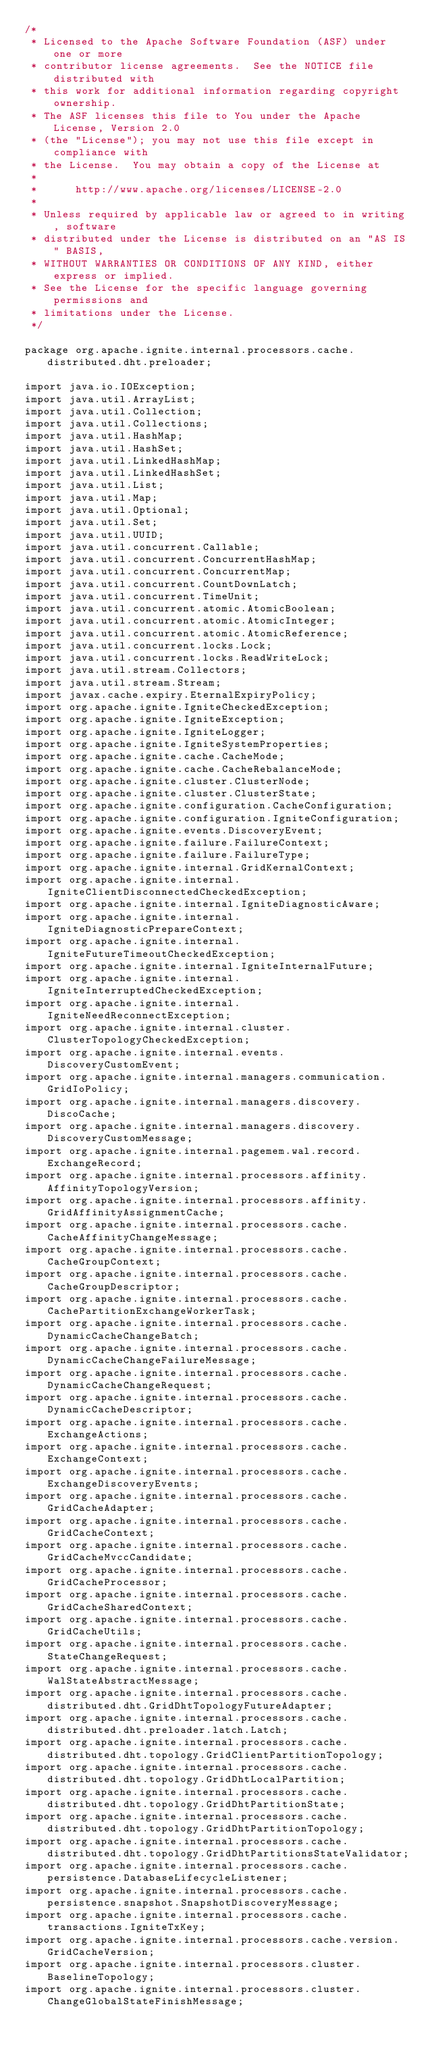<code> <loc_0><loc_0><loc_500><loc_500><_Java_>/*
 * Licensed to the Apache Software Foundation (ASF) under one or more
 * contributor license agreements.  See the NOTICE file distributed with
 * this work for additional information regarding copyright ownership.
 * The ASF licenses this file to You under the Apache License, Version 2.0
 * (the "License"); you may not use this file except in compliance with
 * the License.  You may obtain a copy of the License at
 *
 *      http://www.apache.org/licenses/LICENSE-2.0
 *
 * Unless required by applicable law or agreed to in writing, software
 * distributed under the License is distributed on an "AS IS" BASIS,
 * WITHOUT WARRANTIES OR CONDITIONS OF ANY KIND, either express or implied.
 * See the License for the specific language governing permissions and
 * limitations under the License.
 */

package org.apache.ignite.internal.processors.cache.distributed.dht.preloader;

import java.io.IOException;
import java.util.ArrayList;
import java.util.Collection;
import java.util.Collections;
import java.util.HashMap;
import java.util.HashSet;
import java.util.LinkedHashMap;
import java.util.LinkedHashSet;
import java.util.List;
import java.util.Map;
import java.util.Optional;
import java.util.Set;
import java.util.UUID;
import java.util.concurrent.Callable;
import java.util.concurrent.ConcurrentHashMap;
import java.util.concurrent.ConcurrentMap;
import java.util.concurrent.CountDownLatch;
import java.util.concurrent.TimeUnit;
import java.util.concurrent.atomic.AtomicBoolean;
import java.util.concurrent.atomic.AtomicInteger;
import java.util.concurrent.atomic.AtomicReference;
import java.util.concurrent.locks.Lock;
import java.util.concurrent.locks.ReadWriteLock;
import java.util.stream.Collectors;
import java.util.stream.Stream;
import javax.cache.expiry.EternalExpiryPolicy;
import org.apache.ignite.IgniteCheckedException;
import org.apache.ignite.IgniteException;
import org.apache.ignite.IgniteLogger;
import org.apache.ignite.IgniteSystemProperties;
import org.apache.ignite.cache.CacheMode;
import org.apache.ignite.cache.CacheRebalanceMode;
import org.apache.ignite.cluster.ClusterNode;
import org.apache.ignite.cluster.ClusterState;
import org.apache.ignite.configuration.CacheConfiguration;
import org.apache.ignite.configuration.IgniteConfiguration;
import org.apache.ignite.events.DiscoveryEvent;
import org.apache.ignite.failure.FailureContext;
import org.apache.ignite.failure.FailureType;
import org.apache.ignite.internal.GridKernalContext;
import org.apache.ignite.internal.IgniteClientDisconnectedCheckedException;
import org.apache.ignite.internal.IgniteDiagnosticAware;
import org.apache.ignite.internal.IgniteDiagnosticPrepareContext;
import org.apache.ignite.internal.IgniteFutureTimeoutCheckedException;
import org.apache.ignite.internal.IgniteInternalFuture;
import org.apache.ignite.internal.IgniteInterruptedCheckedException;
import org.apache.ignite.internal.IgniteNeedReconnectException;
import org.apache.ignite.internal.cluster.ClusterTopologyCheckedException;
import org.apache.ignite.internal.events.DiscoveryCustomEvent;
import org.apache.ignite.internal.managers.communication.GridIoPolicy;
import org.apache.ignite.internal.managers.discovery.DiscoCache;
import org.apache.ignite.internal.managers.discovery.DiscoveryCustomMessage;
import org.apache.ignite.internal.pagemem.wal.record.ExchangeRecord;
import org.apache.ignite.internal.processors.affinity.AffinityTopologyVersion;
import org.apache.ignite.internal.processors.affinity.GridAffinityAssignmentCache;
import org.apache.ignite.internal.processors.cache.CacheAffinityChangeMessage;
import org.apache.ignite.internal.processors.cache.CacheGroupContext;
import org.apache.ignite.internal.processors.cache.CacheGroupDescriptor;
import org.apache.ignite.internal.processors.cache.CachePartitionExchangeWorkerTask;
import org.apache.ignite.internal.processors.cache.DynamicCacheChangeBatch;
import org.apache.ignite.internal.processors.cache.DynamicCacheChangeFailureMessage;
import org.apache.ignite.internal.processors.cache.DynamicCacheChangeRequest;
import org.apache.ignite.internal.processors.cache.DynamicCacheDescriptor;
import org.apache.ignite.internal.processors.cache.ExchangeActions;
import org.apache.ignite.internal.processors.cache.ExchangeContext;
import org.apache.ignite.internal.processors.cache.ExchangeDiscoveryEvents;
import org.apache.ignite.internal.processors.cache.GridCacheAdapter;
import org.apache.ignite.internal.processors.cache.GridCacheContext;
import org.apache.ignite.internal.processors.cache.GridCacheMvccCandidate;
import org.apache.ignite.internal.processors.cache.GridCacheProcessor;
import org.apache.ignite.internal.processors.cache.GridCacheSharedContext;
import org.apache.ignite.internal.processors.cache.GridCacheUtils;
import org.apache.ignite.internal.processors.cache.StateChangeRequest;
import org.apache.ignite.internal.processors.cache.WalStateAbstractMessage;
import org.apache.ignite.internal.processors.cache.distributed.dht.GridDhtTopologyFutureAdapter;
import org.apache.ignite.internal.processors.cache.distributed.dht.preloader.latch.Latch;
import org.apache.ignite.internal.processors.cache.distributed.dht.topology.GridClientPartitionTopology;
import org.apache.ignite.internal.processors.cache.distributed.dht.topology.GridDhtLocalPartition;
import org.apache.ignite.internal.processors.cache.distributed.dht.topology.GridDhtPartitionState;
import org.apache.ignite.internal.processors.cache.distributed.dht.topology.GridDhtPartitionTopology;
import org.apache.ignite.internal.processors.cache.distributed.dht.topology.GridDhtPartitionsStateValidator;
import org.apache.ignite.internal.processors.cache.persistence.DatabaseLifecycleListener;
import org.apache.ignite.internal.processors.cache.persistence.snapshot.SnapshotDiscoveryMessage;
import org.apache.ignite.internal.processors.cache.transactions.IgniteTxKey;
import org.apache.ignite.internal.processors.cache.version.GridCacheVersion;
import org.apache.ignite.internal.processors.cluster.BaselineTopology;
import org.apache.ignite.internal.processors.cluster.ChangeGlobalStateFinishMessage;</code> 